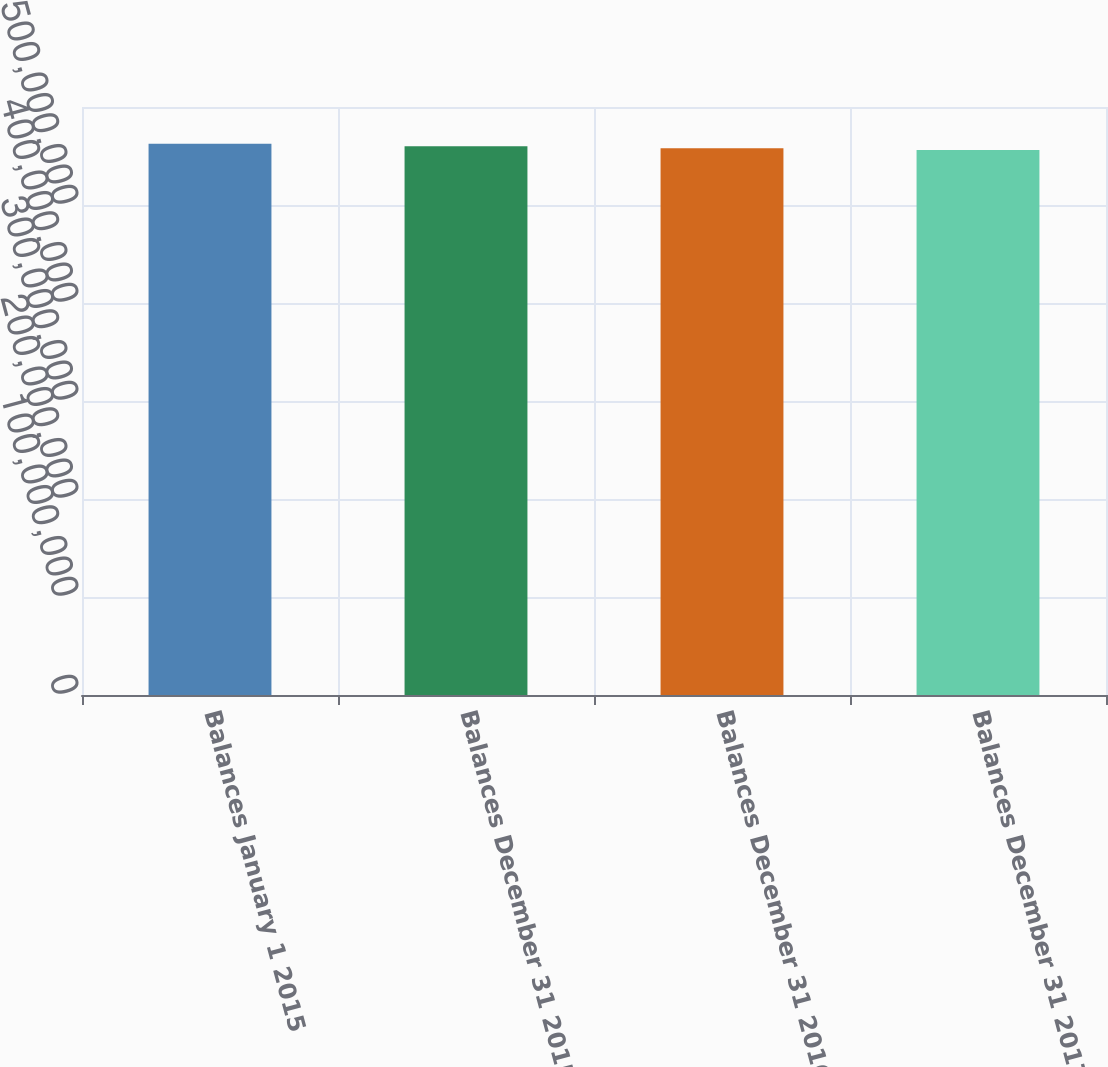Convert chart. <chart><loc_0><loc_0><loc_500><loc_500><bar_chart><fcel>Balances January 1 2015<fcel>Balances December 31 2015<fcel>Balances December 31 2016<fcel>Balances December 31 2017<nl><fcel>5.62417e+08<fcel>5.59972e+08<fcel>5.57931e+08<fcel>5.56099e+08<nl></chart> 